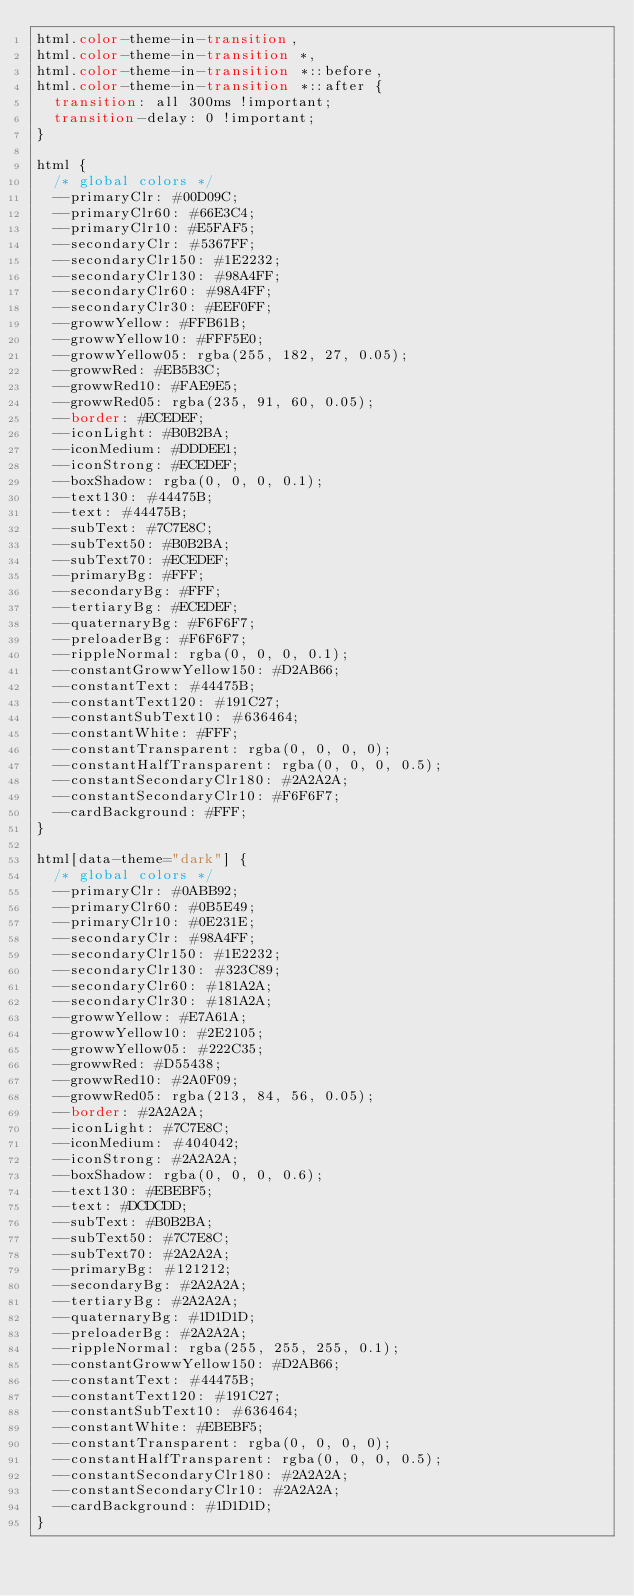Convert code to text. <code><loc_0><loc_0><loc_500><loc_500><_CSS_>html.color-theme-in-transition,
html.color-theme-in-transition *,
html.color-theme-in-transition *::before,
html.color-theme-in-transition *::after {
  transition: all 300ms !important;
  transition-delay: 0 !important;
}

html {
  /* global colors */
  --primaryClr: #00D09C;
  --primaryClr60: #66E3C4;
  --primaryClr10: #E5FAF5;
  --secondaryClr: #5367FF;
  --secondaryClr150: #1E2232;
  --secondaryClr130: #98A4FF;
  --secondaryClr60: #98A4FF;
  --secondaryClr30: #EEF0FF;
  --growwYellow: #FFB61B;
  --growwYellow10: #FFF5E0;
  --growwYellow05: rgba(255, 182, 27, 0.05);
  --growwRed: #EB5B3C;
  --growwRed10: #FAE9E5;
  --growwRed05: rgba(235, 91, 60, 0.05);
  --border: #ECEDEF;
  --iconLight: #B0B2BA;
  --iconMedium: #DDDEE1;
  --iconStrong: #ECEDEF;
  --boxShadow: rgba(0, 0, 0, 0.1);
  --text130: #44475B;
  --text: #44475B;
  --subText: #7C7E8C;
  --subText50: #B0B2BA;
  --subText70: #ECEDEF;
  --primaryBg: #FFF;
  --secondaryBg: #FFF;
  --tertiaryBg: #ECEDEF;
  --quaternaryBg: #F6F6F7;
  --preloaderBg: #F6F6F7;
  --rippleNormal: rgba(0, 0, 0, 0.1);
  --constantGrowwYellow150: #D2AB66;
  --constantText: #44475B;
  --constantText120: #191C27;
  --constantSubText10: #636464;
  --constantWhite: #FFF;
  --constantTransparent: rgba(0, 0, 0, 0);
  --constantHalfTransparent: rgba(0, 0, 0, 0.5);
  --constantSecondaryClr180: #2A2A2A;
  --constantSecondaryClr10: #F6F6F7;
  --cardBackground: #FFF;
}

html[data-theme="dark"] {
  /* global colors */
  --primaryClr: #0ABB92;
  --primaryClr60: #0B5E49;
  --primaryClr10: #0E231E;
  --secondaryClr: #98A4FF;
  --secondaryClr150: #1E2232;
  --secondaryClr130: #323C89;
  --secondaryClr60: #181A2A;
  --secondaryClr30: #181A2A;
  --growwYellow: #E7A61A;
  --growwYellow10: #2E2105;
  --growwYellow05: #222C35;
  --growwRed: #D55438;
  --growwRed10: #2A0F09;
  --growwRed05: rgba(213, 84, 56, 0.05);
  --border: #2A2A2A;
  --iconLight: #7C7E8C;
  --iconMedium: #404042;
  --iconStrong: #2A2A2A;
  --boxShadow: rgba(0, 0, 0, 0.6);
  --text130: #EBEBF5;
  --text: #DCDCDD;
  --subText: #B0B2BA;
  --subText50: #7C7E8C;
  --subText70: #2A2A2A;
  --primaryBg: #121212;
  --secondaryBg: #2A2A2A;
  --tertiaryBg: #2A2A2A;
  --quaternaryBg: #1D1D1D;
  --preloaderBg: #2A2A2A;
  --rippleNormal: rgba(255, 255, 255, 0.1);
  --constantGrowwYellow150: #D2AB66;
  --constantText: #44475B;
  --constantText120: #191C27;
  --constantSubText10: #636464;
  --constantWhite: #EBEBF5;
  --constantTransparent: rgba(0, 0, 0, 0);
  --constantHalfTransparent: rgba(0, 0, 0, 0.5);
  --constantSecondaryClr180: #2A2A2A;
  --constantSecondaryClr10: #2A2A2A;
  --cardBackground: #1D1D1D;
}
</code> 